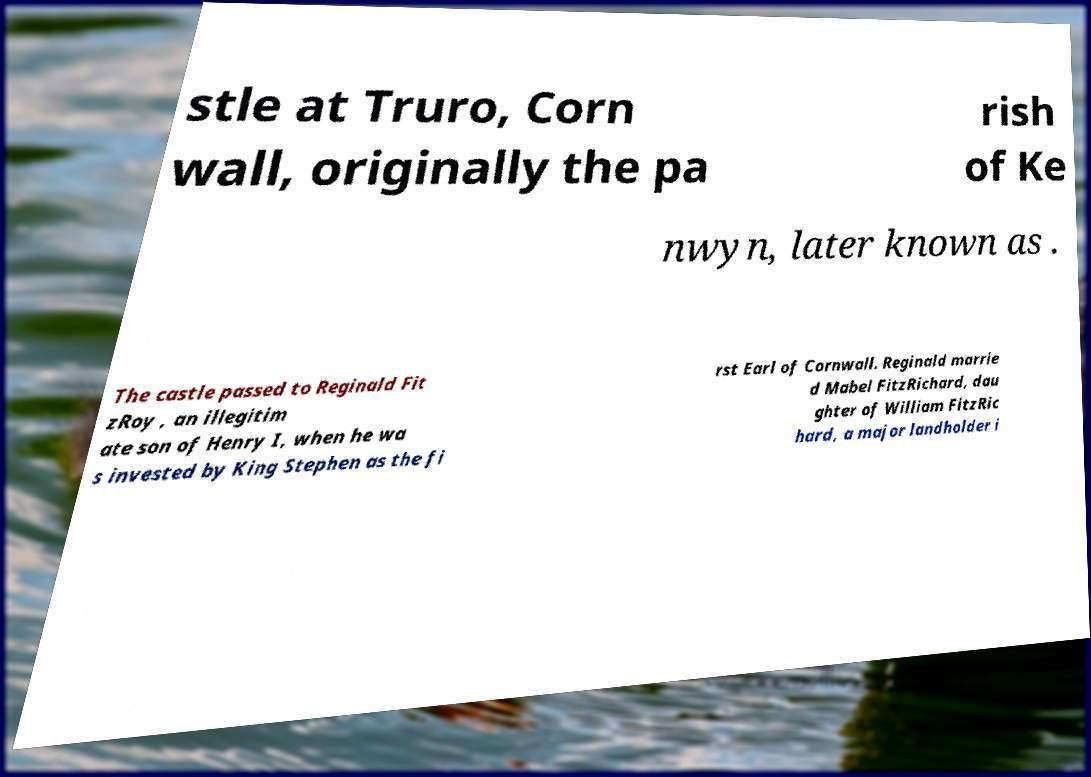Please identify and transcribe the text found in this image. stle at Truro, Corn wall, originally the pa rish of Ke nwyn, later known as . The castle passed to Reginald Fit zRoy , an illegitim ate son of Henry I, when he wa s invested by King Stephen as the fi rst Earl of Cornwall. Reginald marrie d Mabel FitzRichard, dau ghter of William FitzRic hard, a major landholder i 